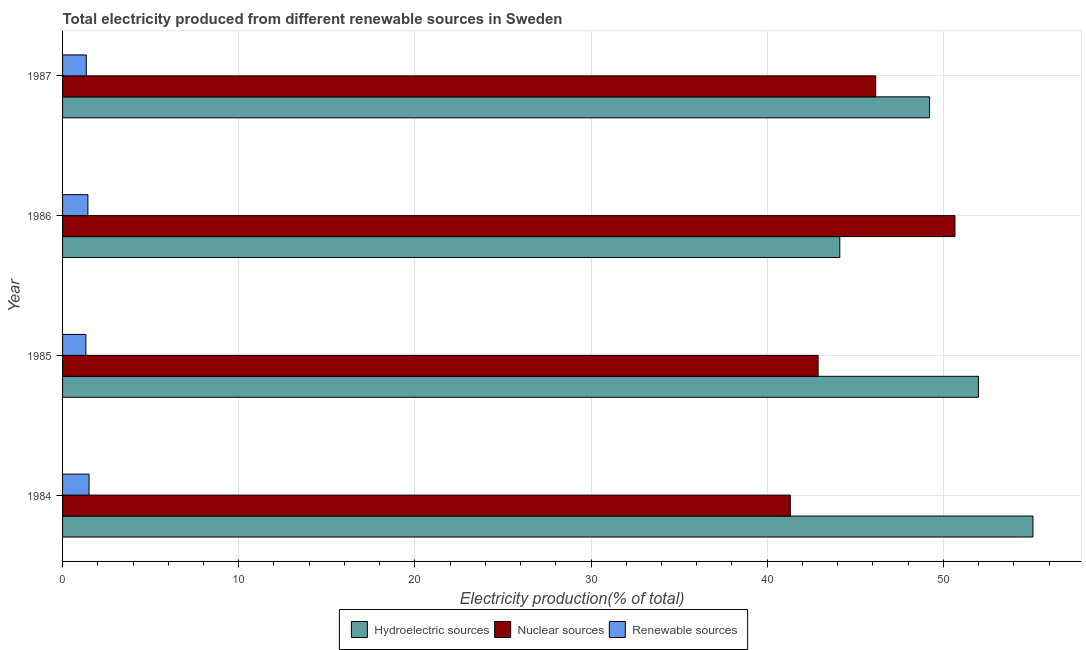How many different coloured bars are there?
Offer a terse response. 3. How many groups of bars are there?
Ensure brevity in your answer.  4. Are the number of bars on each tick of the Y-axis equal?
Ensure brevity in your answer.  Yes. What is the label of the 4th group of bars from the top?
Your response must be concise. 1984. What is the percentage of electricity produced by nuclear sources in 1987?
Make the answer very short. 46.16. Across all years, what is the maximum percentage of electricity produced by renewable sources?
Your response must be concise. 1.5. Across all years, what is the minimum percentage of electricity produced by nuclear sources?
Give a very brief answer. 41.31. What is the total percentage of electricity produced by renewable sources in the graph?
Make the answer very short. 5.61. What is the difference between the percentage of electricity produced by renewable sources in 1985 and that in 1987?
Your answer should be very brief. -0.02. What is the difference between the percentage of electricity produced by hydroelectric sources in 1986 and the percentage of electricity produced by nuclear sources in 1984?
Offer a terse response. 2.81. What is the average percentage of electricity produced by hydroelectric sources per year?
Your answer should be very brief. 50.1. In the year 1986, what is the difference between the percentage of electricity produced by nuclear sources and percentage of electricity produced by renewable sources?
Provide a succinct answer. 49.22. In how many years, is the percentage of electricity produced by nuclear sources greater than 36 %?
Provide a succinct answer. 4. What is the ratio of the percentage of electricity produced by nuclear sources in 1986 to that in 1987?
Make the answer very short. 1.1. Is the percentage of electricity produced by nuclear sources in 1984 less than that in 1986?
Provide a succinct answer. Yes. What is the difference between the highest and the second highest percentage of electricity produced by hydroelectric sources?
Give a very brief answer. 3.1. What is the difference between the highest and the lowest percentage of electricity produced by nuclear sources?
Keep it short and to the point. 9.35. In how many years, is the percentage of electricity produced by hydroelectric sources greater than the average percentage of electricity produced by hydroelectric sources taken over all years?
Offer a terse response. 2. Is the sum of the percentage of electricity produced by renewable sources in 1984 and 1985 greater than the maximum percentage of electricity produced by nuclear sources across all years?
Make the answer very short. No. What does the 1st bar from the top in 1986 represents?
Your answer should be very brief. Renewable sources. What does the 2nd bar from the bottom in 1985 represents?
Provide a succinct answer. Nuclear sources. Is it the case that in every year, the sum of the percentage of electricity produced by hydroelectric sources and percentage of electricity produced by nuclear sources is greater than the percentage of electricity produced by renewable sources?
Give a very brief answer. Yes. How many years are there in the graph?
Your response must be concise. 4. Are the values on the major ticks of X-axis written in scientific E-notation?
Provide a succinct answer. No. Does the graph contain grids?
Your answer should be very brief. Yes. What is the title of the graph?
Give a very brief answer. Total electricity produced from different renewable sources in Sweden. What is the Electricity production(% of total) in Hydroelectric sources in 1984?
Your answer should be very brief. 55.09. What is the Electricity production(% of total) in Nuclear sources in 1984?
Ensure brevity in your answer.  41.31. What is the Electricity production(% of total) of Renewable sources in 1984?
Your answer should be compact. 1.5. What is the Electricity production(% of total) of Hydroelectric sources in 1985?
Offer a very short reply. 51.99. What is the Electricity production(% of total) of Nuclear sources in 1985?
Offer a terse response. 42.89. What is the Electricity production(% of total) of Renewable sources in 1985?
Offer a very short reply. 1.32. What is the Electricity production(% of total) of Hydroelectric sources in 1986?
Your response must be concise. 44.12. What is the Electricity production(% of total) in Nuclear sources in 1986?
Provide a short and direct response. 50.66. What is the Electricity production(% of total) in Renewable sources in 1986?
Your response must be concise. 1.44. What is the Electricity production(% of total) of Hydroelectric sources in 1987?
Your answer should be compact. 49.22. What is the Electricity production(% of total) of Nuclear sources in 1987?
Give a very brief answer. 46.16. What is the Electricity production(% of total) of Renewable sources in 1987?
Provide a short and direct response. 1.35. Across all years, what is the maximum Electricity production(% of total) in Hydroelectric sources?
Provide a short and direct response. 55.09. Across all years, what is the maximum Electricity production(% of total) of Nuclear sources?
Your response must be concise. 50.66. Across all years, what is the maximum Electricity production(% of total) in Renewable sources?
Offer a very short reply. 1.5. Across all years, what is the minimum Electricity production(% of total) in Hydroelectric sources?
Keep it short and to the point. 44.12. Across all years, what is the minimum Electricity production(% of total) of Nuclear sources?
Your response must be concise. 41.31. Across all years, what is the minimum Electricity production(% of total) of Renewable sources?
Your answer should be very brief. 1.32. What is the total Electricity production(% of total) in Hydroelectric sources in the graph?
Your response must be concise. 200.42. What is the total Electricity production(% of total) in Nuclear sources in the graph?
Make the answer very short. 181.02. What is the total Electricity production(% of total) of Renewable sources in the graph?
Provide a short and direct response. 5.61. What is the difference between the Electricity production(% of total) in Hydroelectric sources in 1984 and that in 1985?
Keep it short and to the point. 3.1. What is the difference between the Electricity production(% of total) in Nuclear sources in 1984 and that in 1985?
Make the answer very short. -1.58. What is the difference between the Electricity production(% of total) in Renewable sources in 1984 and that in 1985?
Provide a succinct answer. 0.18. What is the difference between the Electricity production(% of total) of Hydroelectric sources in 1984 and that in 1986?
Ensure brevity in your answer.  10.96. What is the difference between the Electricity production(% of total) in Nuclear sources in 1984 and that in 1986?
Provide a short and direct response. -9.35. What is the difference between the Electricity production(% of total) in Renewable sources in 1984 and that in 1986?
Ensure brevity in your answer.  0.07. What is the difference between the Electricity production(% of total) in Hydroelectric sources in 1984 and that in 1987?
Ensure brevity in your answer.  5.87. What is the difference between the Electricity production(% of total) of Nuclear sources in 1984 and that in 1987?
Give a very brief answer. -4.85. What is the difference between the Electricity production(% of total) of Renewable sources in 1984 and that in 1987?
Give a very brief answer. 0.16. What is the difference between the Electricity production(% of total) of Hydroelectric sources in 1985 and that in 1986?
Keep it short and to the point. 7.87. What is the difference between the Electricity production(% of total) in Nuclear sources in 1985 and that in 1986?
Ensure brevity in your answer.  -7.77. What is the difference between the Electricity production(% of total) of Renewable sources in 1985 and that in 1986?
Keep it short and to the point. -0.11. What is the difference between the Electricity production(% of total) of Hydroelectric sources in 1985 and that in 1987?
Ensure brevity in your answer.  2.77. What is the difference between the Electricity production(% of total) of Nuclear sources in 1985 and that in 1987?
Offer a very short reply. -3.27. What is the difference between the Electricity production(% of total) in Renewable sources in 1985 and that in 1987?
Provide a succinct answer. -0.02. What is the difference between the Electricity production(% of total) in Hydroelectric sources in 1986 and that in 1987?
Your response must be concise. -5.1. What is the difference between the Electricity production(% of total) in Nuclear sources in 1986 and that in 1987?
Offer a very short reply. 4.5. What is the difference between the Electricity production(% of total) of Renewable sources in 1986 and that in 1987?
Provide a short and direct response. 0.09. What is the difference between the Electricity production(% of total) in Hydroelectric sources in 1984 and the Electricity production(% of total) in Nuclear sources in 1985?
Your answer should be very brief. 12.2. What is the difference between the Electricity production(% of total) of Hydroelectric sources in 1984 and the Electricity production(% of total) of Renewable sources in 1985?
Make the answer very short. 53.76. What is the difference between the Electricity production(% of total) of Nuclear sources in 1984 and the Electricity production(% of total) of Renewable sources in 1985?
Give a very brief answer. 39.99. What is the difference between the Electricity production(% of total) of Hydroelectric sources in 1984 and the Electricity production(% of total) of Nuclear sources in 1986?
Your answer should be very brief. 4.43. What is the difference between the Electricity production(% of total) in Hydroelectric sources in 1984 and the Electricity production(% of total) in Renewable sources in 1986?
Offer a very short reply. 53.65. What is the difference between the Electricity production(% of total) of Nuclear sources in 1984 and the Electricity production(% of total) of Renewable sources in 1986?
Your answer should be very brief. 39.88. What is the difference between the Electricity production(% of total) of Hydroelectric sources in 1984 and the Electricity production(% of total) of Nuclear sources in 1987?
Give a very brief answer. 8.93. What is the difference between the Electricity production(% of total) in Hydroelectric sources in 1984 and the Electricity production(% of total) in Renewable sources in 1987?
Offer a terse response. 53.74. What is the difference between the Electricity production(% of total) in Nuclear sources in 1984 and the Electricity production(% of total) in Renewable sources in 1987?
Offer a very short reply. 39.97. What is the difference between the Electricity production(% of total) in Hydroelectric sources in 1985 and the Electricity production(% of total) in Nuclear sources in 1986?
Provide a short and direct response. 1.33. What is the difference between the Electricity production(% of total) in Hydroelectric sources in 1985 and the Electricity production(% of total) in Renewable sources in 1986?
Offer a very short reply. 50.55. What is the difference between the Electricity production(% of total) in Nuclear sources in 1985 and the Electricity production(% of total) in Renewable sources in 1986?
Keep it short and to the point. 41.45. What is the difference between the Electricity production(% of total) of Hydroelectric sources in 1985 and the Electricity production(% of total) of Nuclear sources in 1987?
Your response must be concise. 5.83. What is the difference between the Electricity production(% of total) of Hydroelectric sources in 1985 and the Electricity production(% of total) of Renewable sources in 1987?
Provide a short and direct response. 50.64. What is the difference between the Electricity production(% of total) of Nuclear sources in 1985 and the Electricity production(% of total) of Renewable sources in 1987?
Your answer should be compact. 41.54. What is the difference between the Electricity production(% of total) in Hydroelectric sources in 1986 and the Electricity production(% of total) in Nuclear sources in 1987?
Give a very brief answer. -2.04. What is the difference between the Electricity production(% of total) in Hydroelectric sources in 1986 and the Electricity production(% of total) in Renewable sources in 1987?
Your answer should be very brief. 42.78. What is the difference between the Electricity production(% of total) of Nuclear sources in 1986 and the Electricity production(% of total) of Renewable sources in 1987?
Provide a succinct answer. 49.31. What is the average Electricity production(% of total) of Hydroelectric sources per year?
Give a very brief answer. 50.11. What is the average Electricity production(% of total) of Nuclear sources per year?
Provide a short and direct response. 45.26. What is the average Electricity production(% of total) in Renewable sources per year?
Provide a short and direct response. 1.4. In the year 1984, what is the difference between the Electricity production(% of total) in Hydroelectric sources and Electricity production(% of total) in Nuclear sources?
Provide a succinct answer. 13.77. In the year 1984, what is the difference between the Electricity production(% of total) in Hydroelectric sources and Electricity production(% of total) in Renewable sources?
Make the answer very short. 53.58. In the year 1984, what is the difference between the Electricity production(% of total) of Nuclear sources and Electricity production(% of total) of Renewable sources?
Provide a succinct answer. 39.81. In the year 1985, what is the difference between the Electricity production(% of total) of Hydroelectric sources and Electricity production(% of total) of Nuclear sources?
Provide a short and direct response. 9.1. In the year 1985, what is the difference between the Electricity production(% of total) in Hydroelectric sources and Electricity production(% of total) in Renewable sources?
Your answer should be compact. 50.67. In the year 1985, what is the difference between the Electricity production(% of total) in Nuclear sources and Electricity production(% of total) in Renewable sources?
Ensure brevity in your answer.  41.57. In the year 1986, what is the difference between the Electricity production(% of total) in Hydroelectric sources and Electricity production(% of total) in Nuclear sources?
Your answer should be very brief. -6.54. In the year 1986, what is the difference between the Electricity production(% of total) in Hydroelectric sources and Electricity production(% of total) in Renewable sources?
Offer a terse response. 42.68. In the year 1986, what is the difference between the Electricity production(% of total) of Nuclear sources and Electricity production(% of total) of Renewable sources?
Provide a short and direct response. 49.22. In the year 1987, what is the difference between the Electricity production(% of total) in Hydroelectric sources and Electricity production(% of total) in Nuclear sources?
Provide a succinct answer. 3.06. In the year 1987, what is the difference between the Electricity production(% of total) of Hydroelectric sources and Electricity production(% of total) of Renewable sources?
Keep it short and to the point. 47.87. In the year 1987, what is the difference between the Electricity production(% of total) in Nuclear sources and Electricity production(% of total) in Renewable sources?
Ensure brevity in your answer.  44.82. What is the ratio of the Electricity production(% of total) of Hydroelectric sources in 1984 to that in 1985?
Provide a short and direct response. 1.06. What is the ratio of the Electricity production(% of total) in Nuclear sources in 1984 to that in 1985?
Keep it short and to the point. 0.96. What is the ratio of the Electricity production(% of total) of Renewable sources in 1984 to that in 1985?
Your answer should be very brief. 1.14. What is the ratio of the Electricity production(% of total) in Hydroelectric sources in 1984 to that in 1986?
Keep it short and to the point. 1.25. What is the ratio of the Electricity production(% of total) of Nuclear sources in 1984 to that in 1986?
Your answer should be compact. 0.82. What is the ratio of the Electricity production(% of total) in Renewable sources in 1984 to that in 1986?
Keep it short and to the point. 1.05. What is the ratio of the Electricity production(% of total) in Hydroelectric sources in 1984 to that in 1987?
Provide a short and direct response. 1.12. What is the ratio of the Electricity production(% of total) in Nuclear sources in 1984 to that in 1987?
Your response must be concise. 0.9. What is the ratio of the Electricity production(% of total) in Renewable sources in 1984 to that in 1987?
Offer a very short reply. 1.12. What is the ratio of the Electricity production(% of total) of Hydroelectric sources in 1985 to that in 1986?
Ensure brevity in your answer.  1.18. What is the ratio of the Electricity production(% of total) in Nuclear sources in 1985 to that in 1986?
Provide a succinct answer. 0.85. What is the ratio of the Electricity production(% of total) of Renewable sources in 1985 to that in 1986?
Your answer should be compact. 0.92. What is the ratio of the Electricity production(% of total) of Hydroelectric sources in 1985 to that in 1987?
Provide a succinct answer. 1.06. What is the ratio of the Electricity production(% of total) of Nuclear sources in 1985 to that in 1987?
Offer a very short reply. 0.93. What is the ratio of the Electricity production(% of total) in Renewable sources in 1985 to that in 1987?
Provide a short and direct response. 0.98. What is the ratio of the Electricity production(% of total) in Hydroelectric sources in 1986 to that in 1987?
Your response must be concise. 0.9. What is the ratio of the Electricity production(% of total) in Nuclear sources in 1986 to that in 1987?
Offer a terse response. 1.1. What is the ratio of the Electricity production(% of total) of Renewable sources in 1986 to that in 1987?
Make the answer very short. 1.07. What is the difference between the highest and the second highest Electricity production(% of total) of Hydroelectric sources?
Offer a terse response. 3.1. What is the difference between the highest and the second highest Electricity production(% of total) of Nuclear sources?
Make the answer very short. 4.5. What is the difference between the highest and the second highest Electricity production(% of total) of Renewable sources?
Keep it short and to the point. 0.07. What is the difference between the highest and the lowest Electricity production(% of total) in Hydroelectric sources?
Keep it short and to the point. 10.96. What is the difference between the highest and the lowest Electricity production(% of total) of Nuclear sources?
Offer a very short reply. 9.35. What is the difference between the highest and the lowest Electricity production(% of total) of Renewable sources?
Provide a short and direct response. 0.18. 